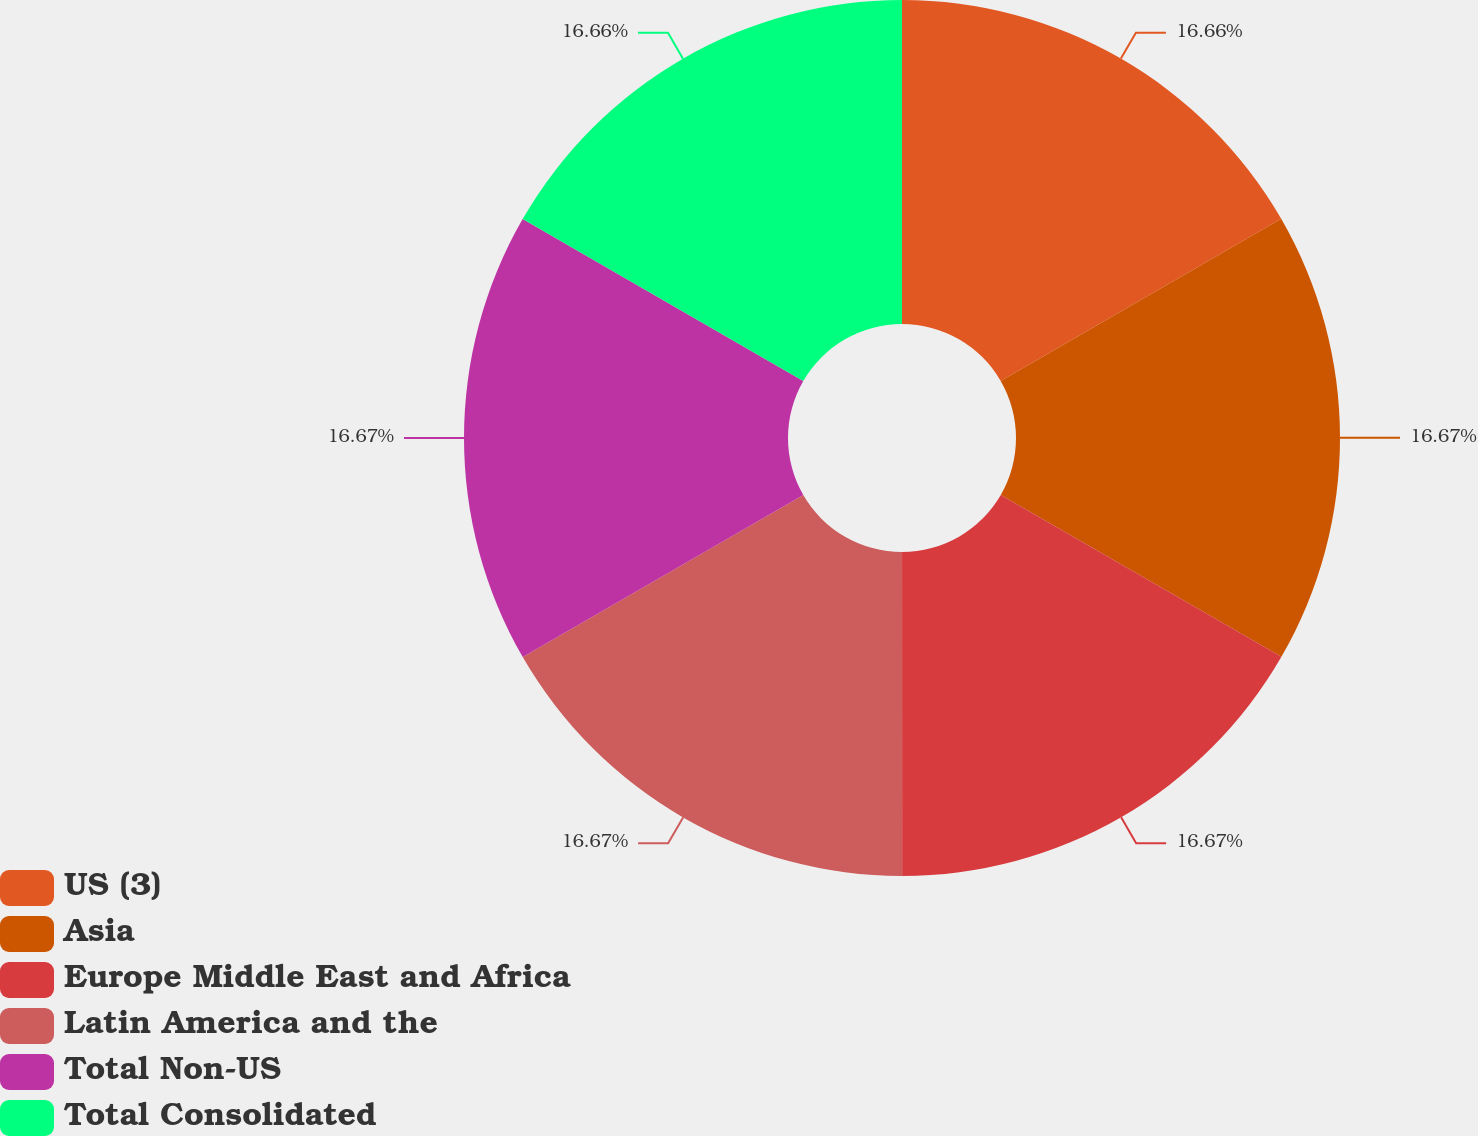<chart> <loc_0><loc_0><loc_500><loc_500><pie_chart><fcel>US (3)<fcel>Asia<fcel>Europe Middle East and Africa<fcel>Latin America and the<fcel>Total Non-US<fcel>Total Consolidated<nl><fcel>16.66%<fcel>16.67%<fcel>16.67%<fcel>16.67%<fcel>16.67%<fcel>16.67%<nl></chart> 